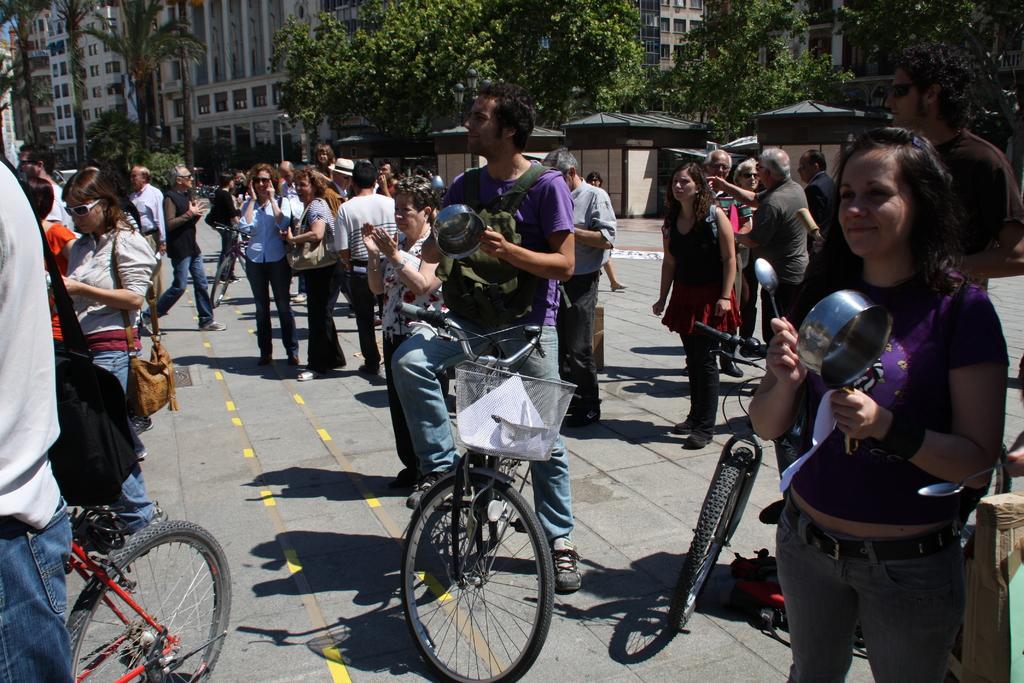How would you summarize this image in a sentence or two? In the image we can see there are people who are standing on the road and few people are sitting on bicycle. 